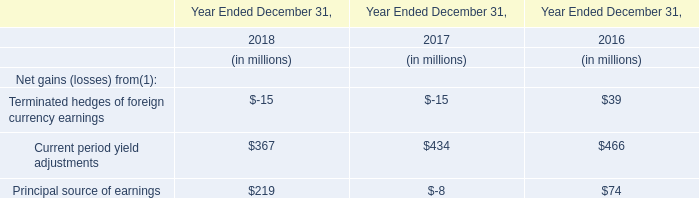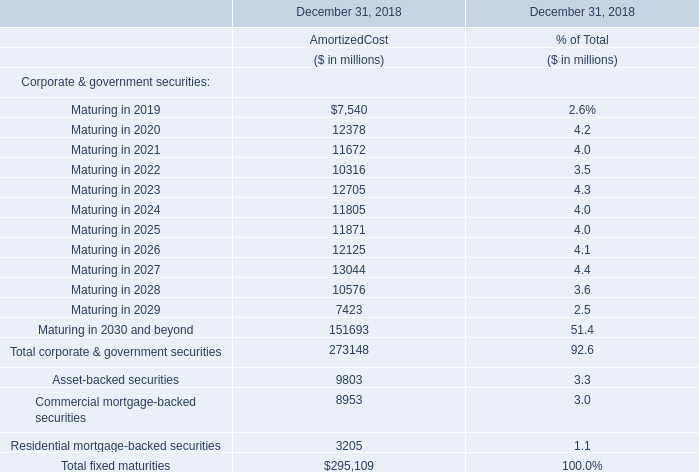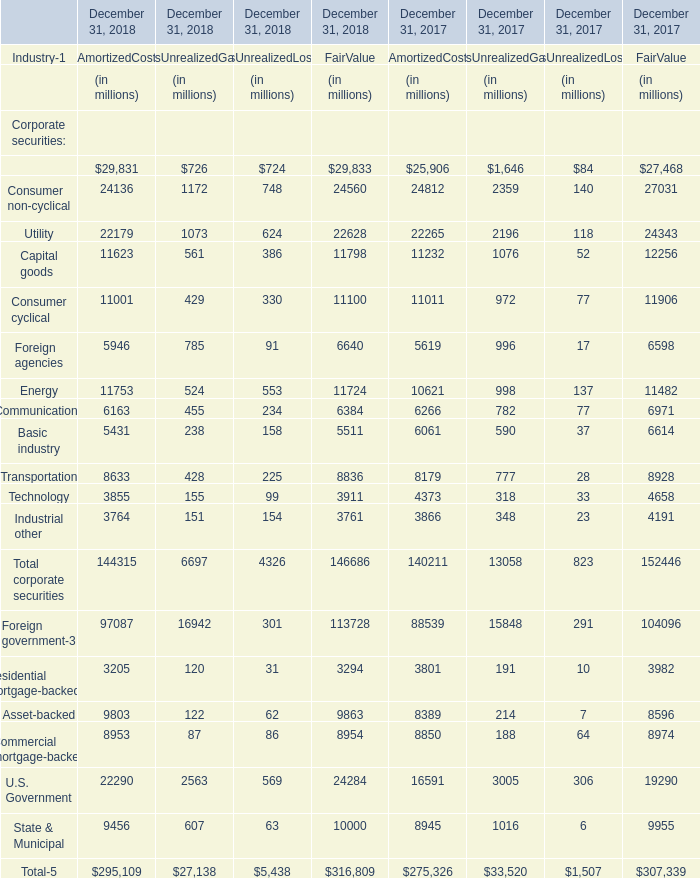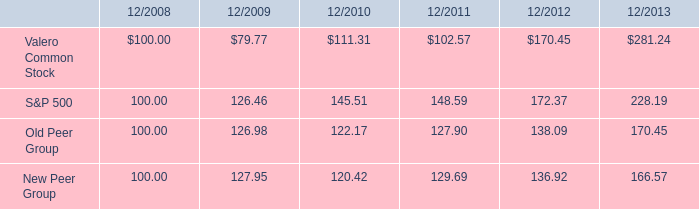what is the total return in valero common stock from 2008-2013? 
Computations: (281.24 - 100)
Answer: 181.24. 